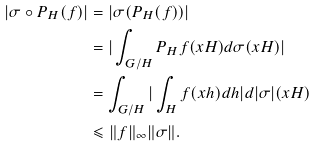<formula> <loc_0><loc_0><loc_500><loc_500>| \sigma \circ P _ { H } ( f ) | & = | \sigma ( P _ { H } ( f ) ) | \\ & = | \int _ { G / H } { P _ { H } f ( x H ) d \sigma ( x H ) } | \\ & = \int _ { G / H } { | \int _ { H } { f ( x h ) d h | d | \sigma | ( x H ) } } \\ & \leqslant \| f \| _ { \infty } \| \sigma \| .</formula> 